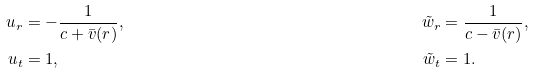<formula> <loc_0><loc_0><loc_500><loc_500>u _ { r } & = - \frac { 1 } { c + \bar { v } ( r ) } , & \quad \tilde { w } _ { r } & = \frac { 1 } { c - \bar { v } ( r ) } , \\ u _ { t } & = 1 , & \quad \tilde { w } _ { t } & = 1 .</formula> 